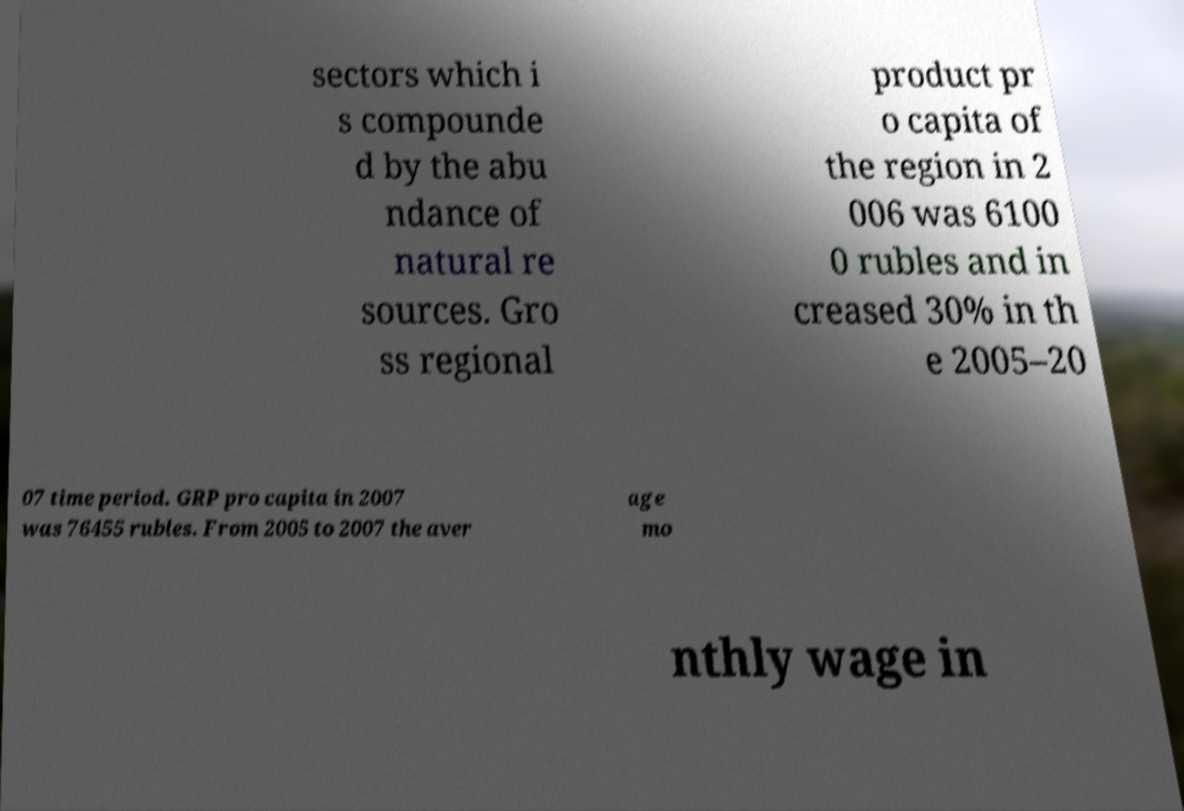There's text embedded in this image that I need extracted. Can you transcribe it verbatim? sectors which i s compounde d by the abu ndance of natural re sources. Gro ss regional product pr o capita of the region in 2 006 was 6100 0 rubles and in creased 30% in th e 2005–20 07 time period. GRP pro capita in 2007 was 76455 rubles. From 2005 to 2007 the aver age mo nthly wage in 